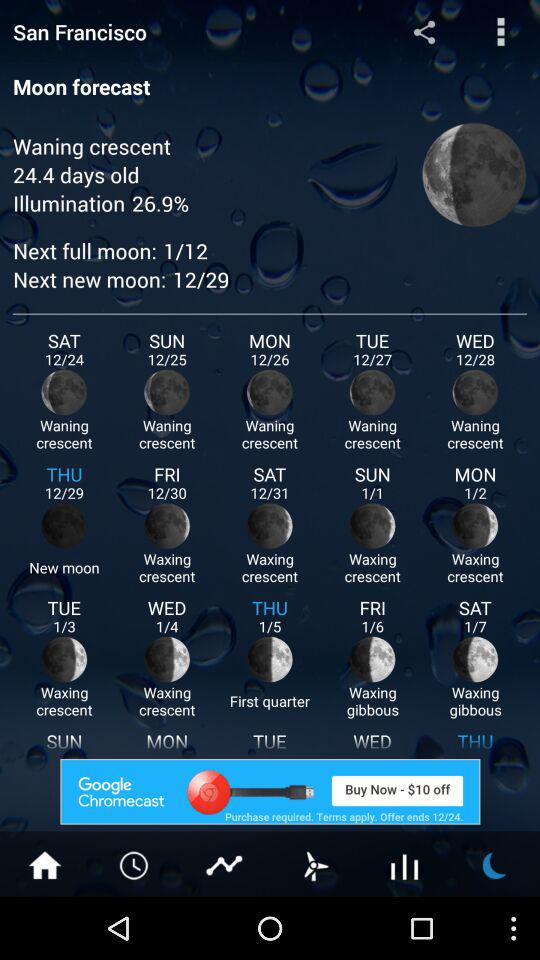What is the location? The location is San Francisco. 